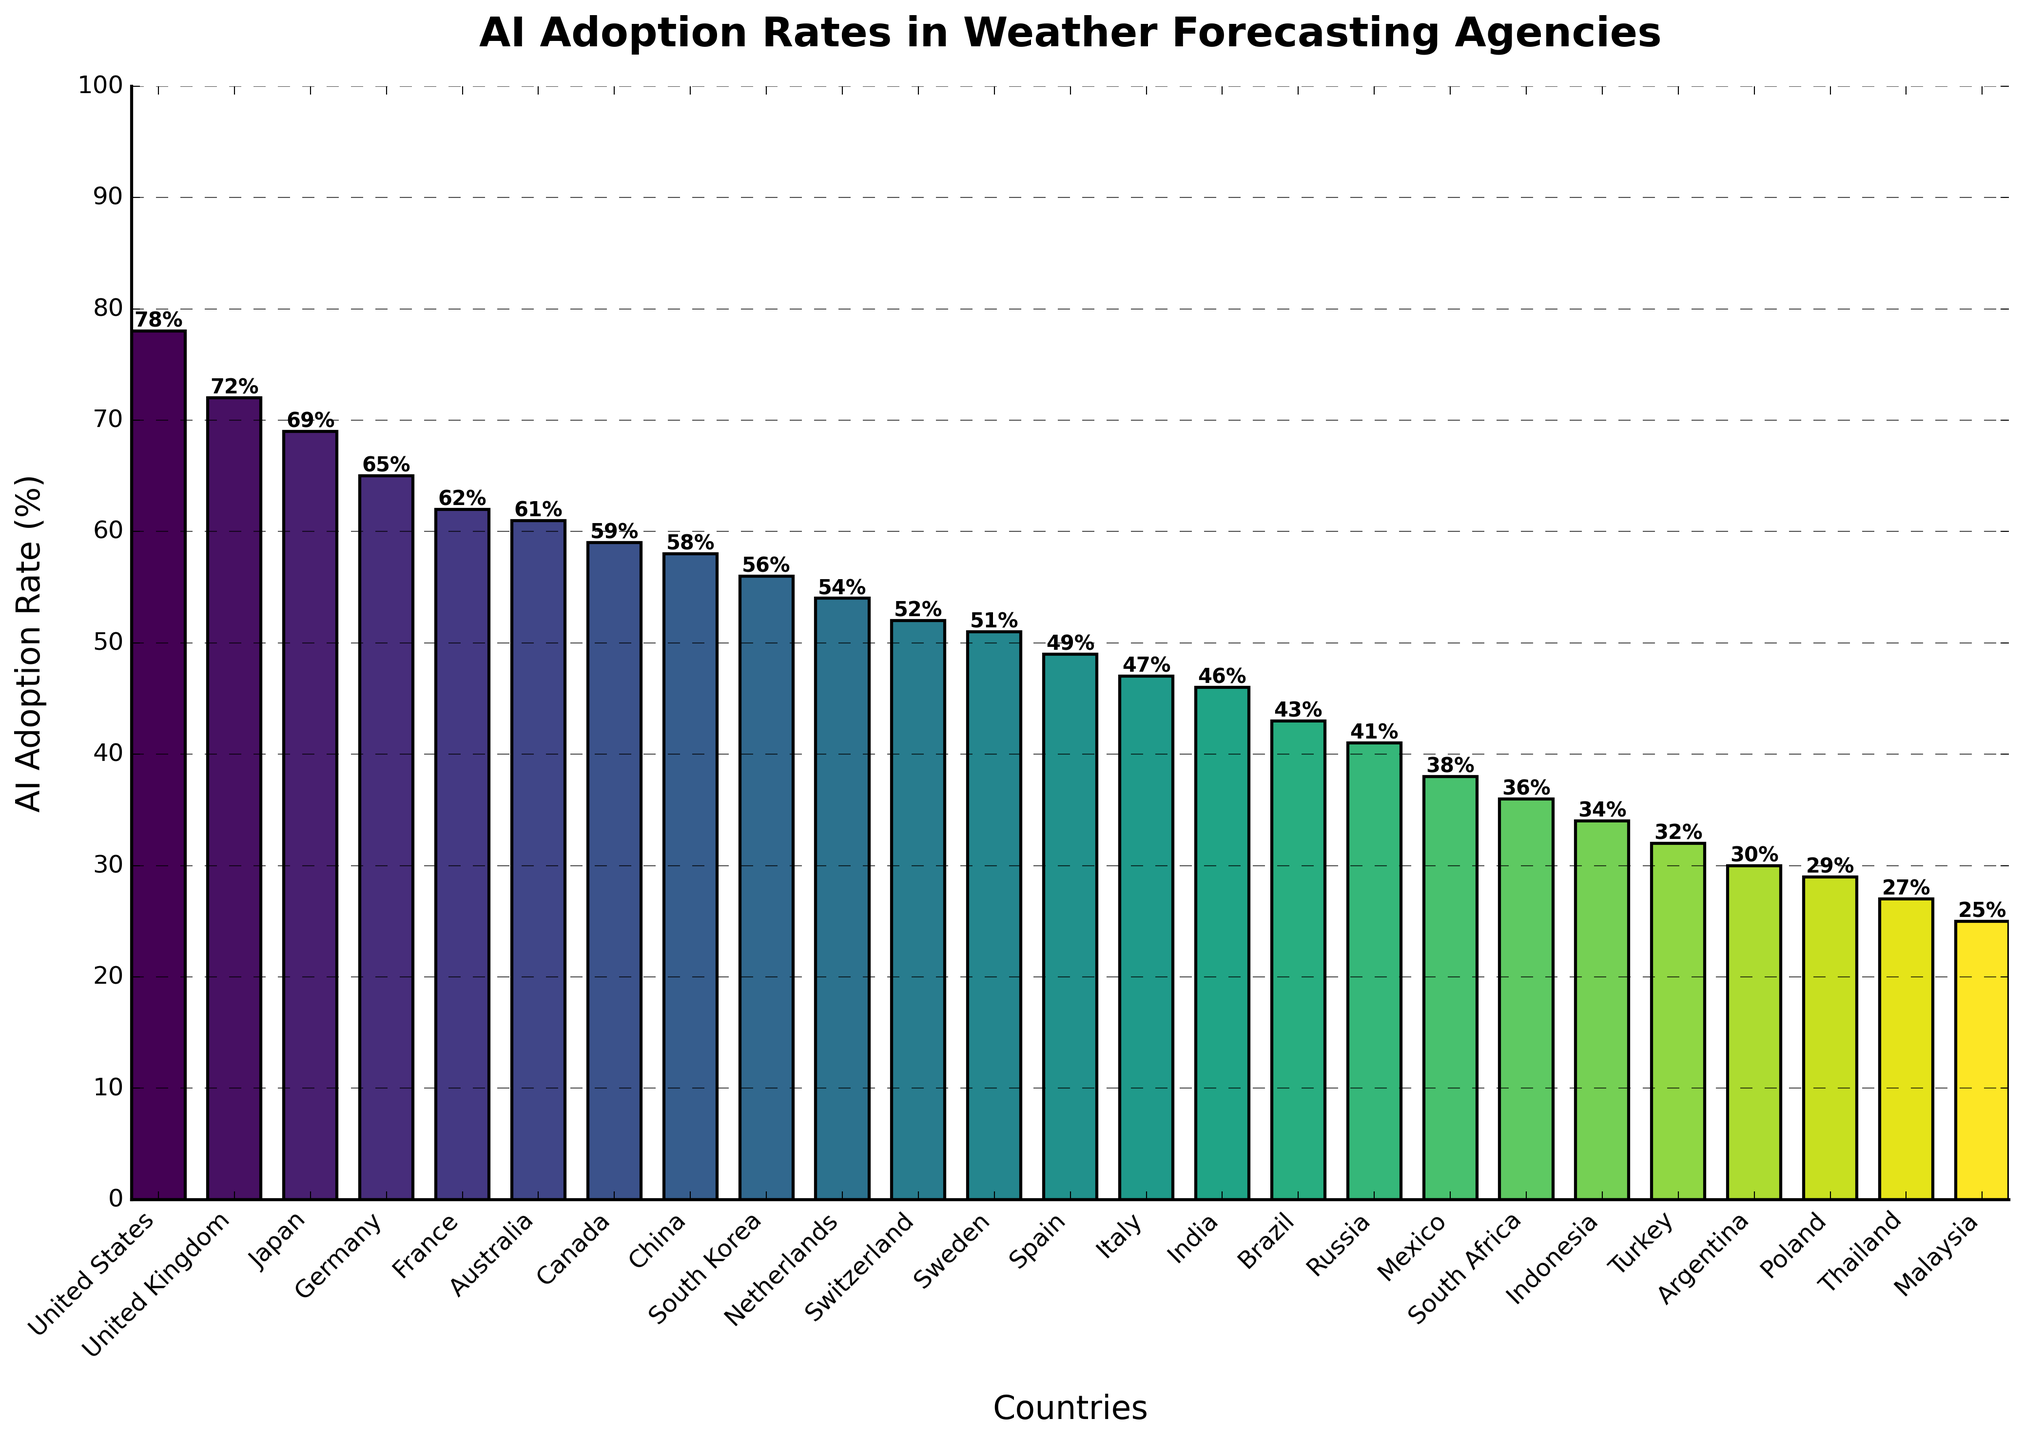What is the AI adoption rate in Japan? Locate the bar corresponding to Japan and read the height of the bar. The height indicates the AI adoption rate.
Answer: 69% Which country has the highest AI adoption rate? Identify the tallest bar on the chart. The country associated with this bar has the highest AI adoption rate.
Answer: United States What is the difference in AI adoption rates between the United States and Indonesia? Locate the bars corresponding to the United States (78%) and Indonesia (34%). Subtract the lower value from the higher value. 78 - 34 = 44
Answer: 44% What is the average AI adoption rate of the top five countries? Identify the top five bars (United States, United Kingdom, Japan, Germany, France). Sum the AI adoption rates (78 + 72 + 69 + 65 + 62 = 346) and divide by 5. 346/5 = 69.2
Answer: 69.2% Which countries have AI adoption rates greater than 60%? Identify the bars which have a height greater than 60% on the y-axis scale, then list the corresponding countries.
Answer: United States, United Kingdom, Japan, Germany, France, Australia How many countries have AI adoption rates less than 50%? Count the number of bars which have a height less than 50% on the y-axis scale.
Answer: 8 What is the AI adoption rate range (difference between highest and lowest rates) across all countries? Find the highest value (78%) and the lowest value (25%) from the bar chart. Subtract the lowest value from the highest value. 78 - 25 = 53
Answer: 53% Compare the AI adoption rates of Australia and Canada. Which has a higher rate and by how much? Locate the bars corresponding to Australia (61%) and Canada (59%). Subtract the lower value from the higher value. 61 - 59 = 2. Australia has a higher rate by 2%.
Answer: Australia, 2% Which nation is represented by the lightest-colored bar on the chart? Identify the bar with the lightest color, which typically indicates the lowest value on a gradient scale, and read the corresponding country name.
Answer: Malaysia What is the median AI adoption rate among the countries listed? List the AI adoption rates, sort them in ascending order, and find the middle value (26 countries, median is the average of the 13th and 14th values). Sorted rates: 25, 27, 29, 30, 32, 34, 36, 38, 41, 43, 46, 47, 49, 51, 52, 54, 56, 58, 59, 61, 62, 65, 69, 72, 78. Median = (49 + 51)/2 = 50
Answer: 50 